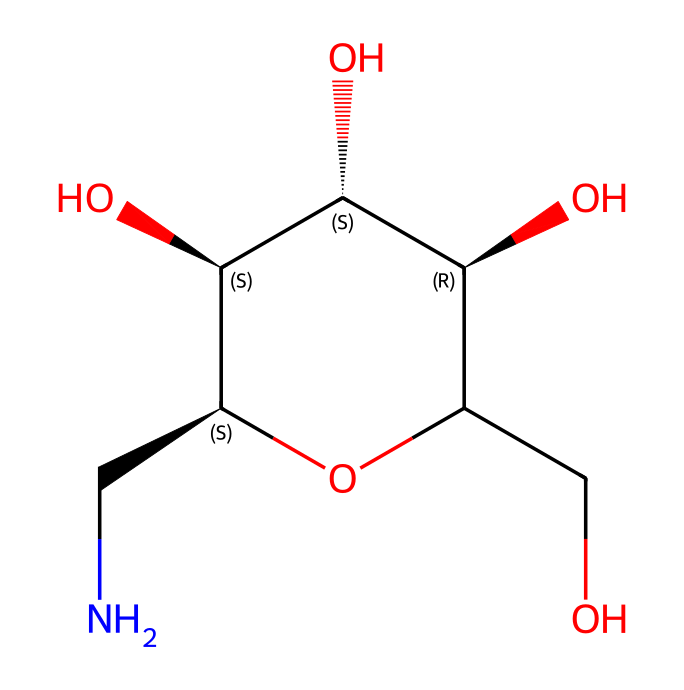What is the molecular formula for glucosamine? The molecular formula is derived from the number of atoms of each element present in the structure. This structure shows that glucosamine contains carbon (C), hydrogen (H), nitrogen (N), and oxygen (O). The count leads us to the formula C6H13NO5.
Answer: C6H13NO5 How many rings are present in the glucosamine structure? Analyzing the SMILES representation for glucosamine, it appears there is one ring structure formed by the atoms indicated in the notation.
Answer: 1 What is the functional group primarily present in chondroitin sulfate? The SMILES representation reveals the presence of a sulfate group (OS(=O)(=O)O) clearly indicated in the structure, which is characteristic of chondroitin sulfate.
Answer: sulfate group Which type of bond connects the nitrogen atom in glucosamine? The nitrogen atom in glucosamine is connected by a single bond to the carbon atom, as indicated by the simple connections in the structural representation.
Answer: single bond What distinguishes chondroitin sulfate from glucosamine in terms of sulfate modification? Chondroitin sulfate contains an attached sulfate group, while glucosamine has only an amine group, which leads to the distinction in their biochemical roles and properties.
Answer: sulfate group How many total oxygen atoms are in chondroitin sulfate? Counting the oxygen atoms in the chondroitin sulfate structure involves identifying all instances of the oxygen symbol in the SMILES until the total is reached, yielding five oxygen atoms.
Answer: 5 